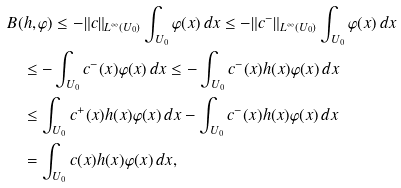Convert formula to latex. <formula><loc_0><loc_0><loc_500><loc_500>& B ( h , \varphi ) \leq - \| c \| _ { L ^ { \infty } ( U _ { 0 } ) } \int _ { U _ { 0 } } \varphi ( x ) \, d x \leq - \| c ^ { - } \| _ { L ^ { \infty } ( U _ { 0 } ) } \int _ { U _ { 0 } } \varphi ( x ) \, d x \\ & \quad \leq - \int _ { U _ { 0 } } c ^ { - } ( x ) \varphi ( x ) \, d x \leq - \int _ { U _ { 0 } } c ^ { - } ( x ) h ( x ) \varphi ( x ) \, d x \\ & \quad \leq \int _ { U _ { 0 } } c ^ { + } ( x ) h ( x ) \varphi ( x ) \, d x - \int _ { U _ { 0 } } c ^ { - } ( x ) h ( x ) \varphi ( x ) \, d x \\ & \quad = \int _ { U _ { 0 } } c ( x ) h ( x ) \varphi ( x ) \, d x ,</formula> 